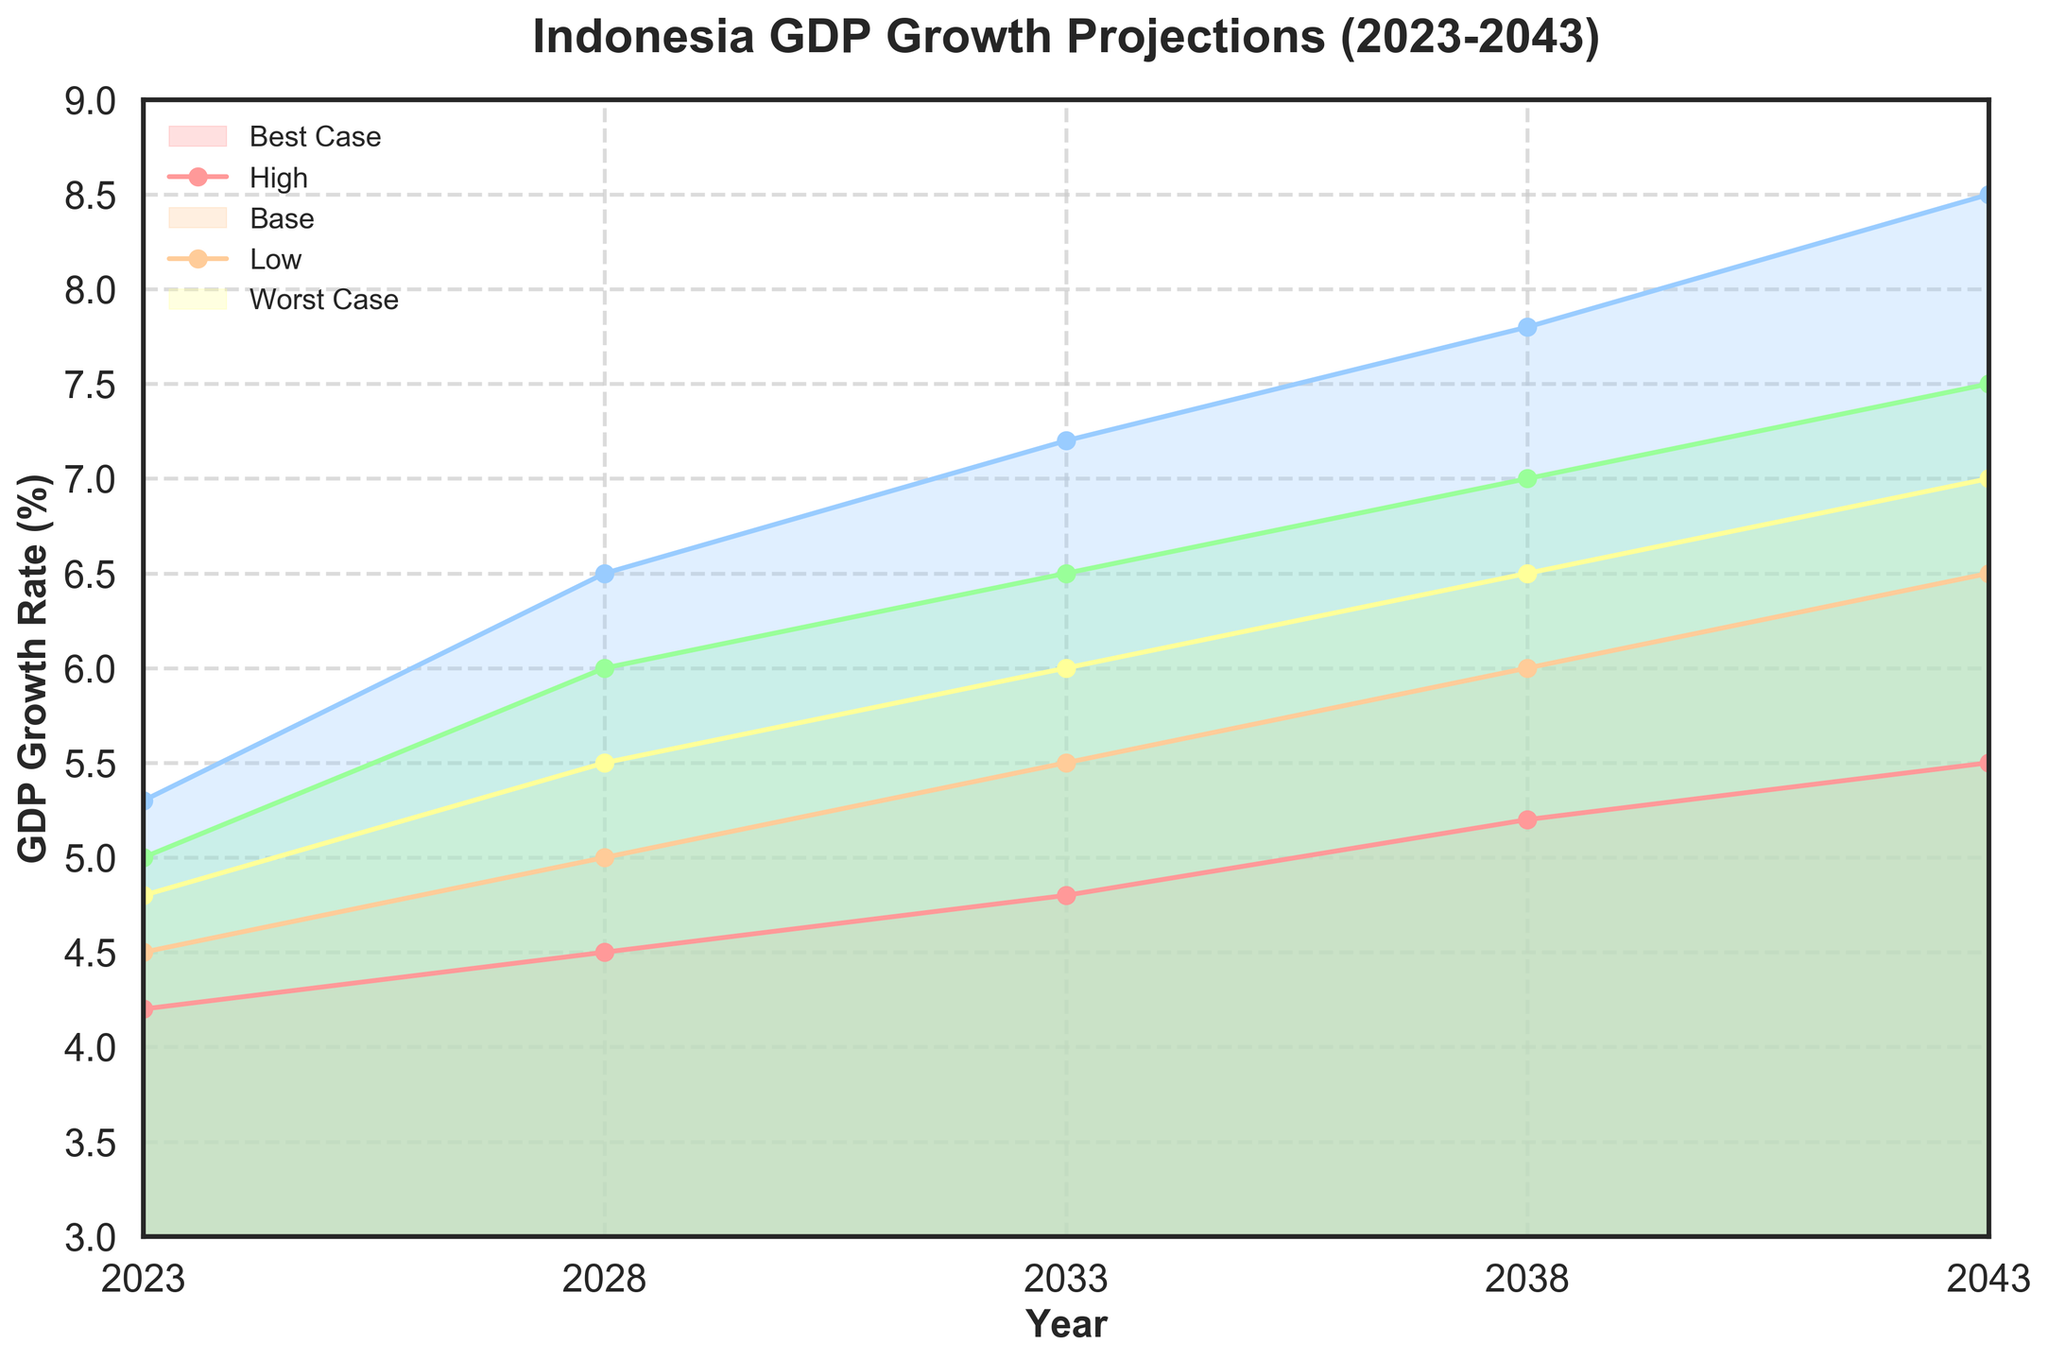What is the title of the plot? The title is displayed at the top of the plot and clearly states what the figure represents.
Answer: Indonesia GDP Growth Projections (2023-2043) What are the years covered by the projection? The x-axis ranges from 2023 to 2043. This range includes each year listed in the plot.
Answer: 2023-2043 How does the base case GDP growth rate change from 2023 to 2043? By observing the base case line, it's clear that it starts at 4.8% in 2023 and ends at 7.0% in 2043.
Answer: Increases from 4.8% to 7.0% What is the GDP growth rate in the worst-case scenario for 2028? By looking at the value of the 'Worst Case' line for the year 2028, we can find the growth rate.
Answer: 4.5% Among Best Case, High, Base, Low, and Worst Case scenarios, which has the highest GDP growth rate in 2043? The highest growth rate in 2043 is represented by the Best Case line on the graph.
Answer: Best Case In which year is the GDP growth rate for the Low scenario exactly 6%? By tracing the Low scenario line, we see that the growth rate is exactly 6% in the year 2038.
Answer: 2038 What is the difference between the Best Case and Worst Case growth rates in 2033? The Best Case growth rate is 7.2% and the Worst Case is 4.8% in 2033. The difference is calculated as 7.2% - 4.8%.
Answer: 2.4% Comparing the High and Low scenarios, in which year do they have the smallest gap? By looking at the vertical distance between High and Low lines across all years, the smallest gap appears in 2023 where the values are 5.0% and 4.5%.
Answer: 2023 What is the average GDP growth rate for the Base case scenario over the 20-year period? The Base case rates are {4.8, 5.5, 6.0, 6.5, 7.0}. Summing these values and dividing by the number of data points gives the average ((4.8 + 5.5 + 6.0 + 6.5 + 7.0) / 5).
Answer: 5.96% How does the trend of GDP growth in the Worst Case scenario compare to the Best Case scenario? The overall trend in both scenarios shows an increase in GDP growth over the years, but the Worst Case grows at a slower and lower rate than the Best Case.
Answer: Slower increase in Worst Case than Best Case 